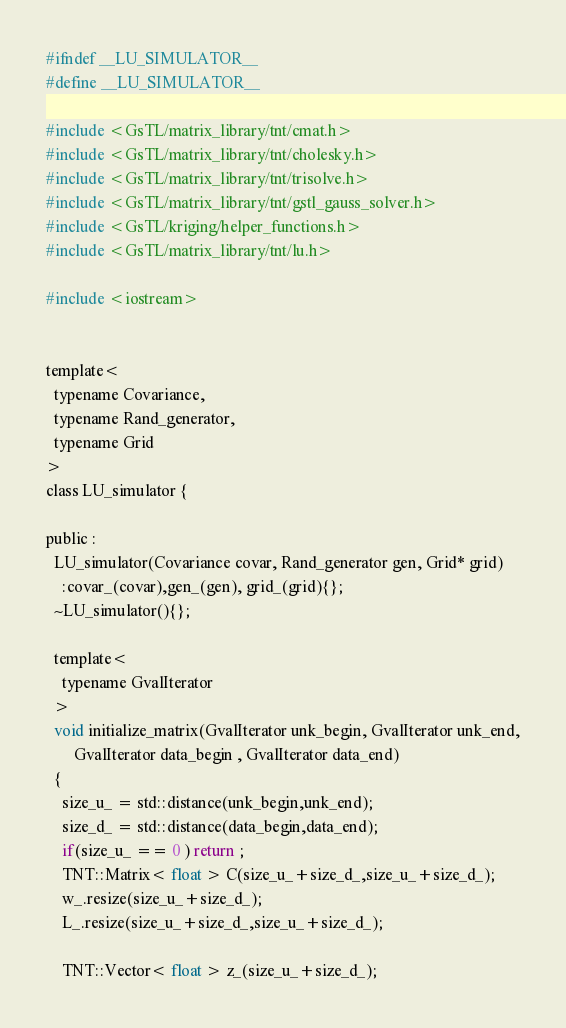Convert code to text. <code><loc_0><loc_0><loc_500><loc_500><_C_>#ifndef __LU_SIMULATOR__
#define __LU_SIMULATOR__

#include <GsTL/matrix_library/tnt/cmat.h>
#include <GsTL/matrix_library/tnt/cholesky.h>
#include <GsTL/matrix_library/tnt/trisolve.h>
#include <GsTL/matrix_library/tnt/gstl_gauss_solver.h>
#include <GsTL/kriging/helper_functions.h>
#include <GsTL/matrix_library/tnt/lu.h>

#include <iostream>


template<
  typename Covariance,
  typename Rand_generator,
  typename Grid
>
class LU_simulator {

public :
  LU_simulator(Covariance covar, Rand_generator gen, Grid* grid)
    :covar_(covar),gen_(gen), grid_(grid){};
  ~LU_simulator(){};

  template<
    typename GvalIterator
  >
  void initialize_matrix(GvalIterator unk_begin, GvalIterator unk_end,
       GvalIterator data_begin , GvalIterator data_end)    
  {
    size_u_ = std::distance(unk_begin,unk_end);
    size_d_ = std::distance(data_begin,data_end);
    if(size_u_ == 0 ) return ;
    TNT::Matrix< float > C(size_u_+size_d_,size_u_+size_d_);
    w_.resize(size_u_+size_d_);
    L_.resize(size_u_+size_d_,size_u_+size_d_);

    TNT::Vector< float > z_(size_u_+size_d_);
</code> 